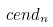<formula> <loc_0><loc_0><loc_500><loc_500>c e n d _ { n }</formula> 